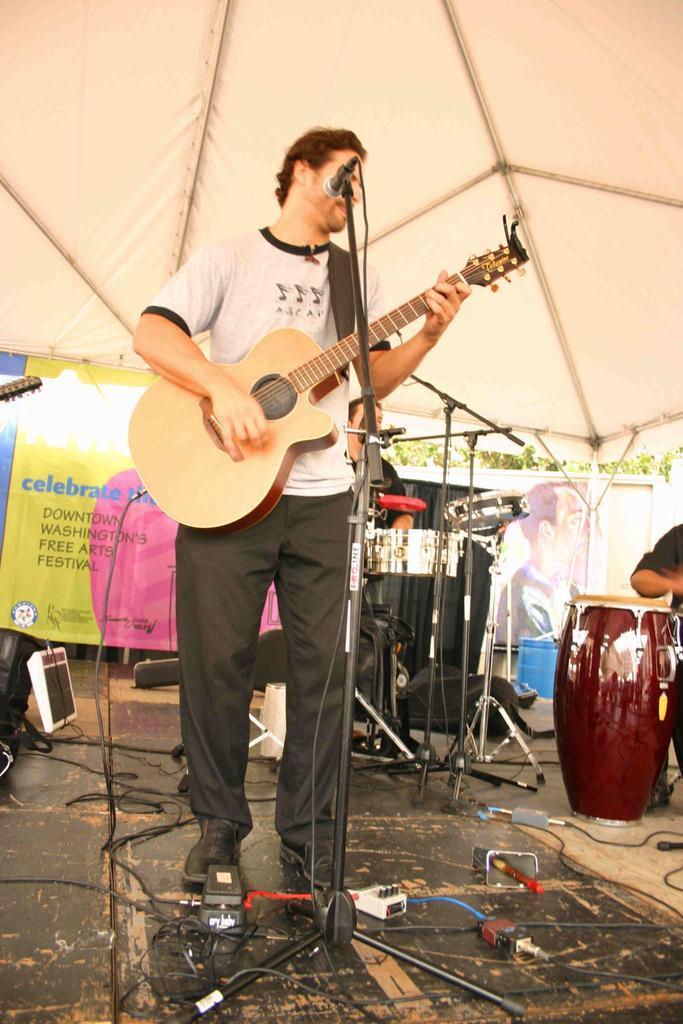Describe this image in one or two sentences. As we can see in the image there is a white color cloth, a man standing over here and the man is holding guitar in his hand and there is a mike and drums. 